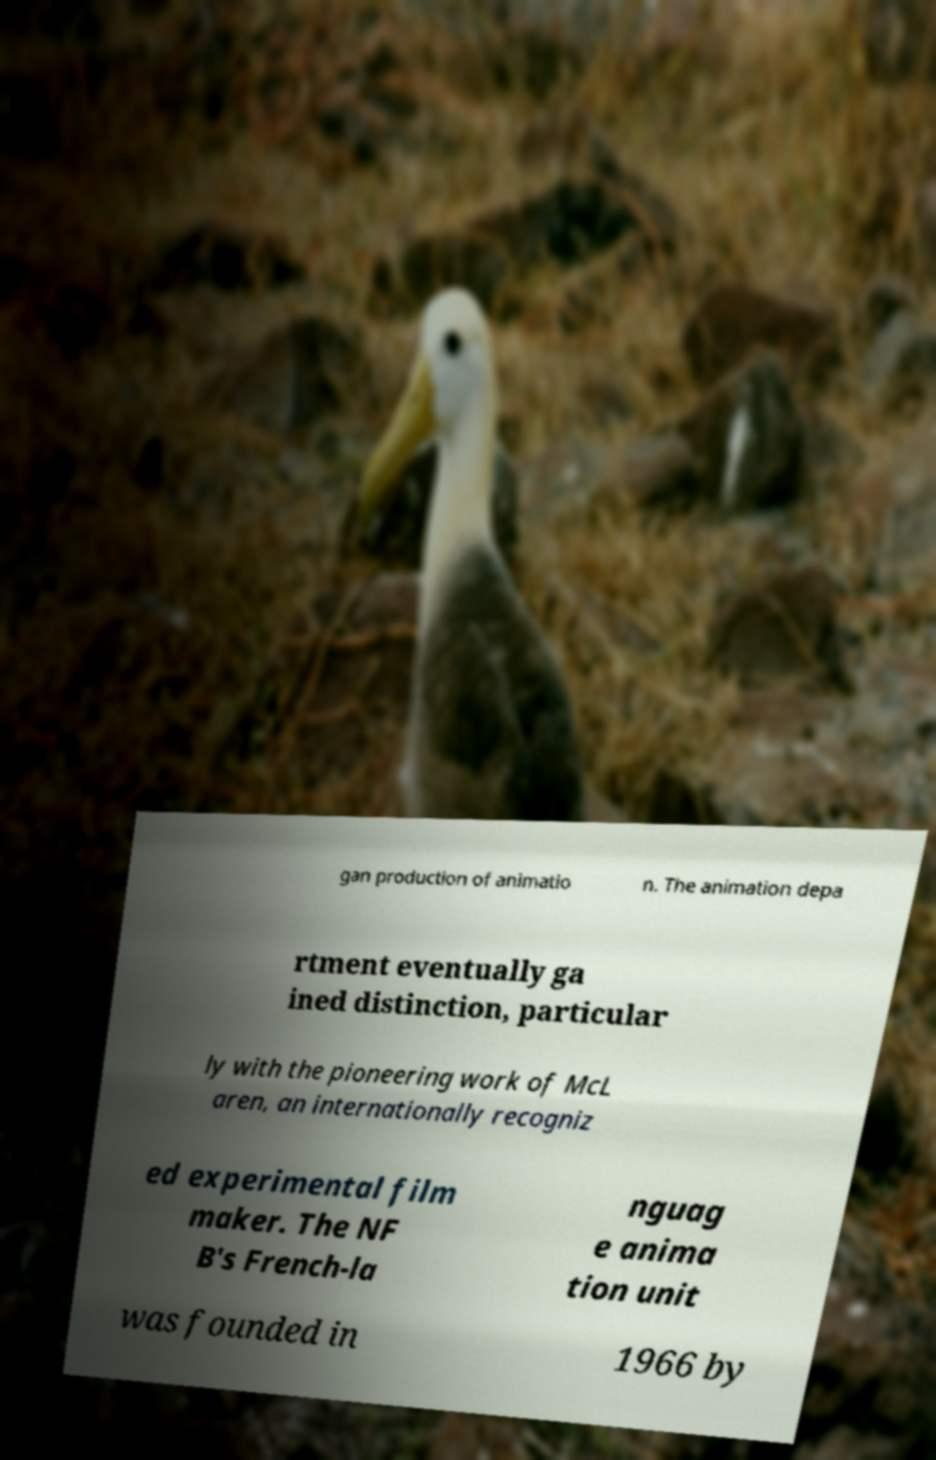I need the written content from this picture converted into text. Can you do that? gan production of animatio n. The animation depa rtment eventually ga ined distinction, particular ly with the pioneering work of McL aren, an internationally recogniz ed experimental film maker. The NF B's French-la nguag e anima tion unit was founded in 1966 by 